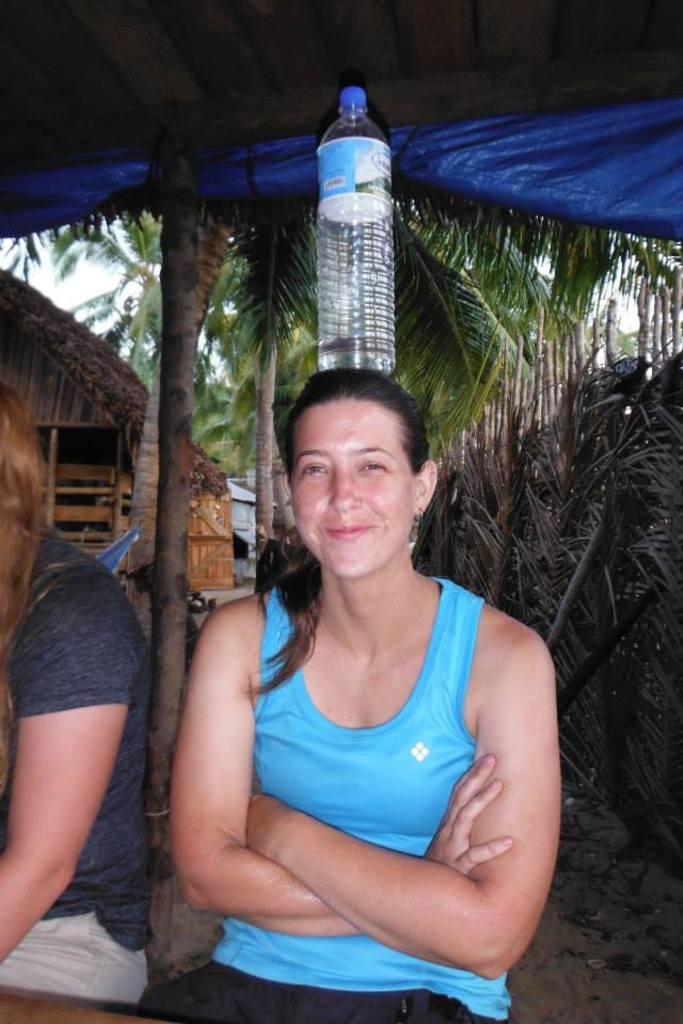What type of natural elements can be seen in the image? There are trees in the image. How many people are present in the image? There are two persons in the image. What object can be seen in addition to the trees and people? There is a bottle in the image. How many babies are wearing hats in the image? There are no babies or hats present in the image. What type of sorting activity is taking place in the image? There is no sorting activity present in the image. 